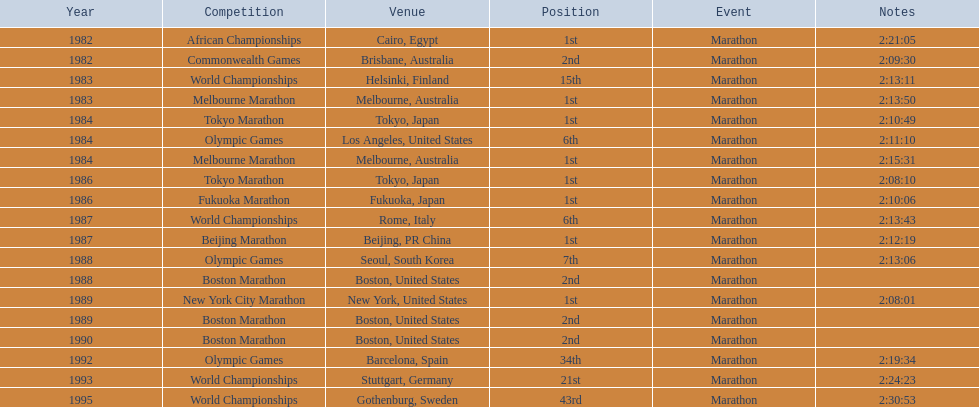What are all of the juma ikangaa events? African Championships, Commonwealth Games, World Championships, Melbourne Marathon, Tokyo Marathon, Olympic Games, Melbourne Marathon, Tokyo Marathon, Fukuoka Marathon, World Championships, Beijing Marathon, Olympic Games, Boston Marathon, New York City Marathon, Boston Marathon, Boston Marathon, Olympic Games, World Championships, World Championships. Which of these events did not transpire in the united states? African Championships, Commonwealth Games, World Championships, Melbourne Marathon, Tokyo Marathon, Melbourne Marathon, Tokyo Marathon, Fukuoka Marathon, World Championships, Beijing Marathon, Olympic Games, Olympic Games, World Championships, World Championships. Out of these, which of them were held in asia? Tokyo Marathon, Tokyo Marathon, Fukuoka Marathon, Beijing Marathon, Olympic Games. Give me the full table as a dictionary. {'header': ['Year', 'Competition', 'Venue', 'Position', 'Event', 'Notes'], 'rows': [['1982', 'African Championships', 'Cairo, Egypt', '1st', 'Marathon', '2:21:05'], ['1982', 'Commonwealth Games', 'Brisbane, Australia', '2nd', 'Marathon', '2:09:30'], ['1983', 'World Championships', 'Helsinki, Finland', '15th', 'Marathon', '2:13:11'], ['1983', 'Melbourne Marathon', 'Melbourne, Australia', '1st', 'Marathon', '2:13:50'], ['1984', 'Tokyo Marathon', 'Tokyo, Japan', '1st', 'Marathon', '2:10:49'], ['1984', 'Olympic Games', 'Los Angeles, United States', '6th', 'Marathon', '2:11:10'], ['1984', 'Melbourne Marathon', 'Melbourne, Australia', '1st', 'Marathon', '2:15:31'], ['1986', 'Tokyo Marathon', 'Tokyo, Japan', '1st', 'Marathon', '2:08:10'], ['1986', 'Fukuoka Marathon', 'Fukuoka, Japan', '1st', 'Marathon', '2:10:06'], ['1987', 'World Championships', 'Rome, Italy', '6th', 'Marathon', '2:13:43'], ['1987', 'Beijing Marathon', 'Beijing, PR China', '1st', 'Marathon', '2:12:19'], ['1988', 'Olympic Games', 'Seoul, South Korea', '7th', 'Marathon', '2:13:06'], ['1988', 'Boston Marathon', 'Boston, United States', '2nd', 'Marathon', ''], ['1989', 'New York City Marathon', 'New York, United States', '1st', 'Marathon', '2:08:01'], ['1989', 'Boston Marathon', 'Boston, United States', '2nd', 'Marathon', ''], ['1990', 'Boston Marathon', 'Boston, United States', '2nd', 'Marathon', ''], ['1992', 'Olympic Games', 'Barcelona, Spain', '34th', 'Marathon', '2:19:34'], ['1993', 'World Championships', 'Stuttgart, Germany', '21st', 'Marathon', '2:24:23'], ['1995', 'World Championships', 'Gothenburg, Sweden', '43rd', 'Marathon', '2:30:53']]} Which of the remaining events were conducted in china? Beijing Marathon. 